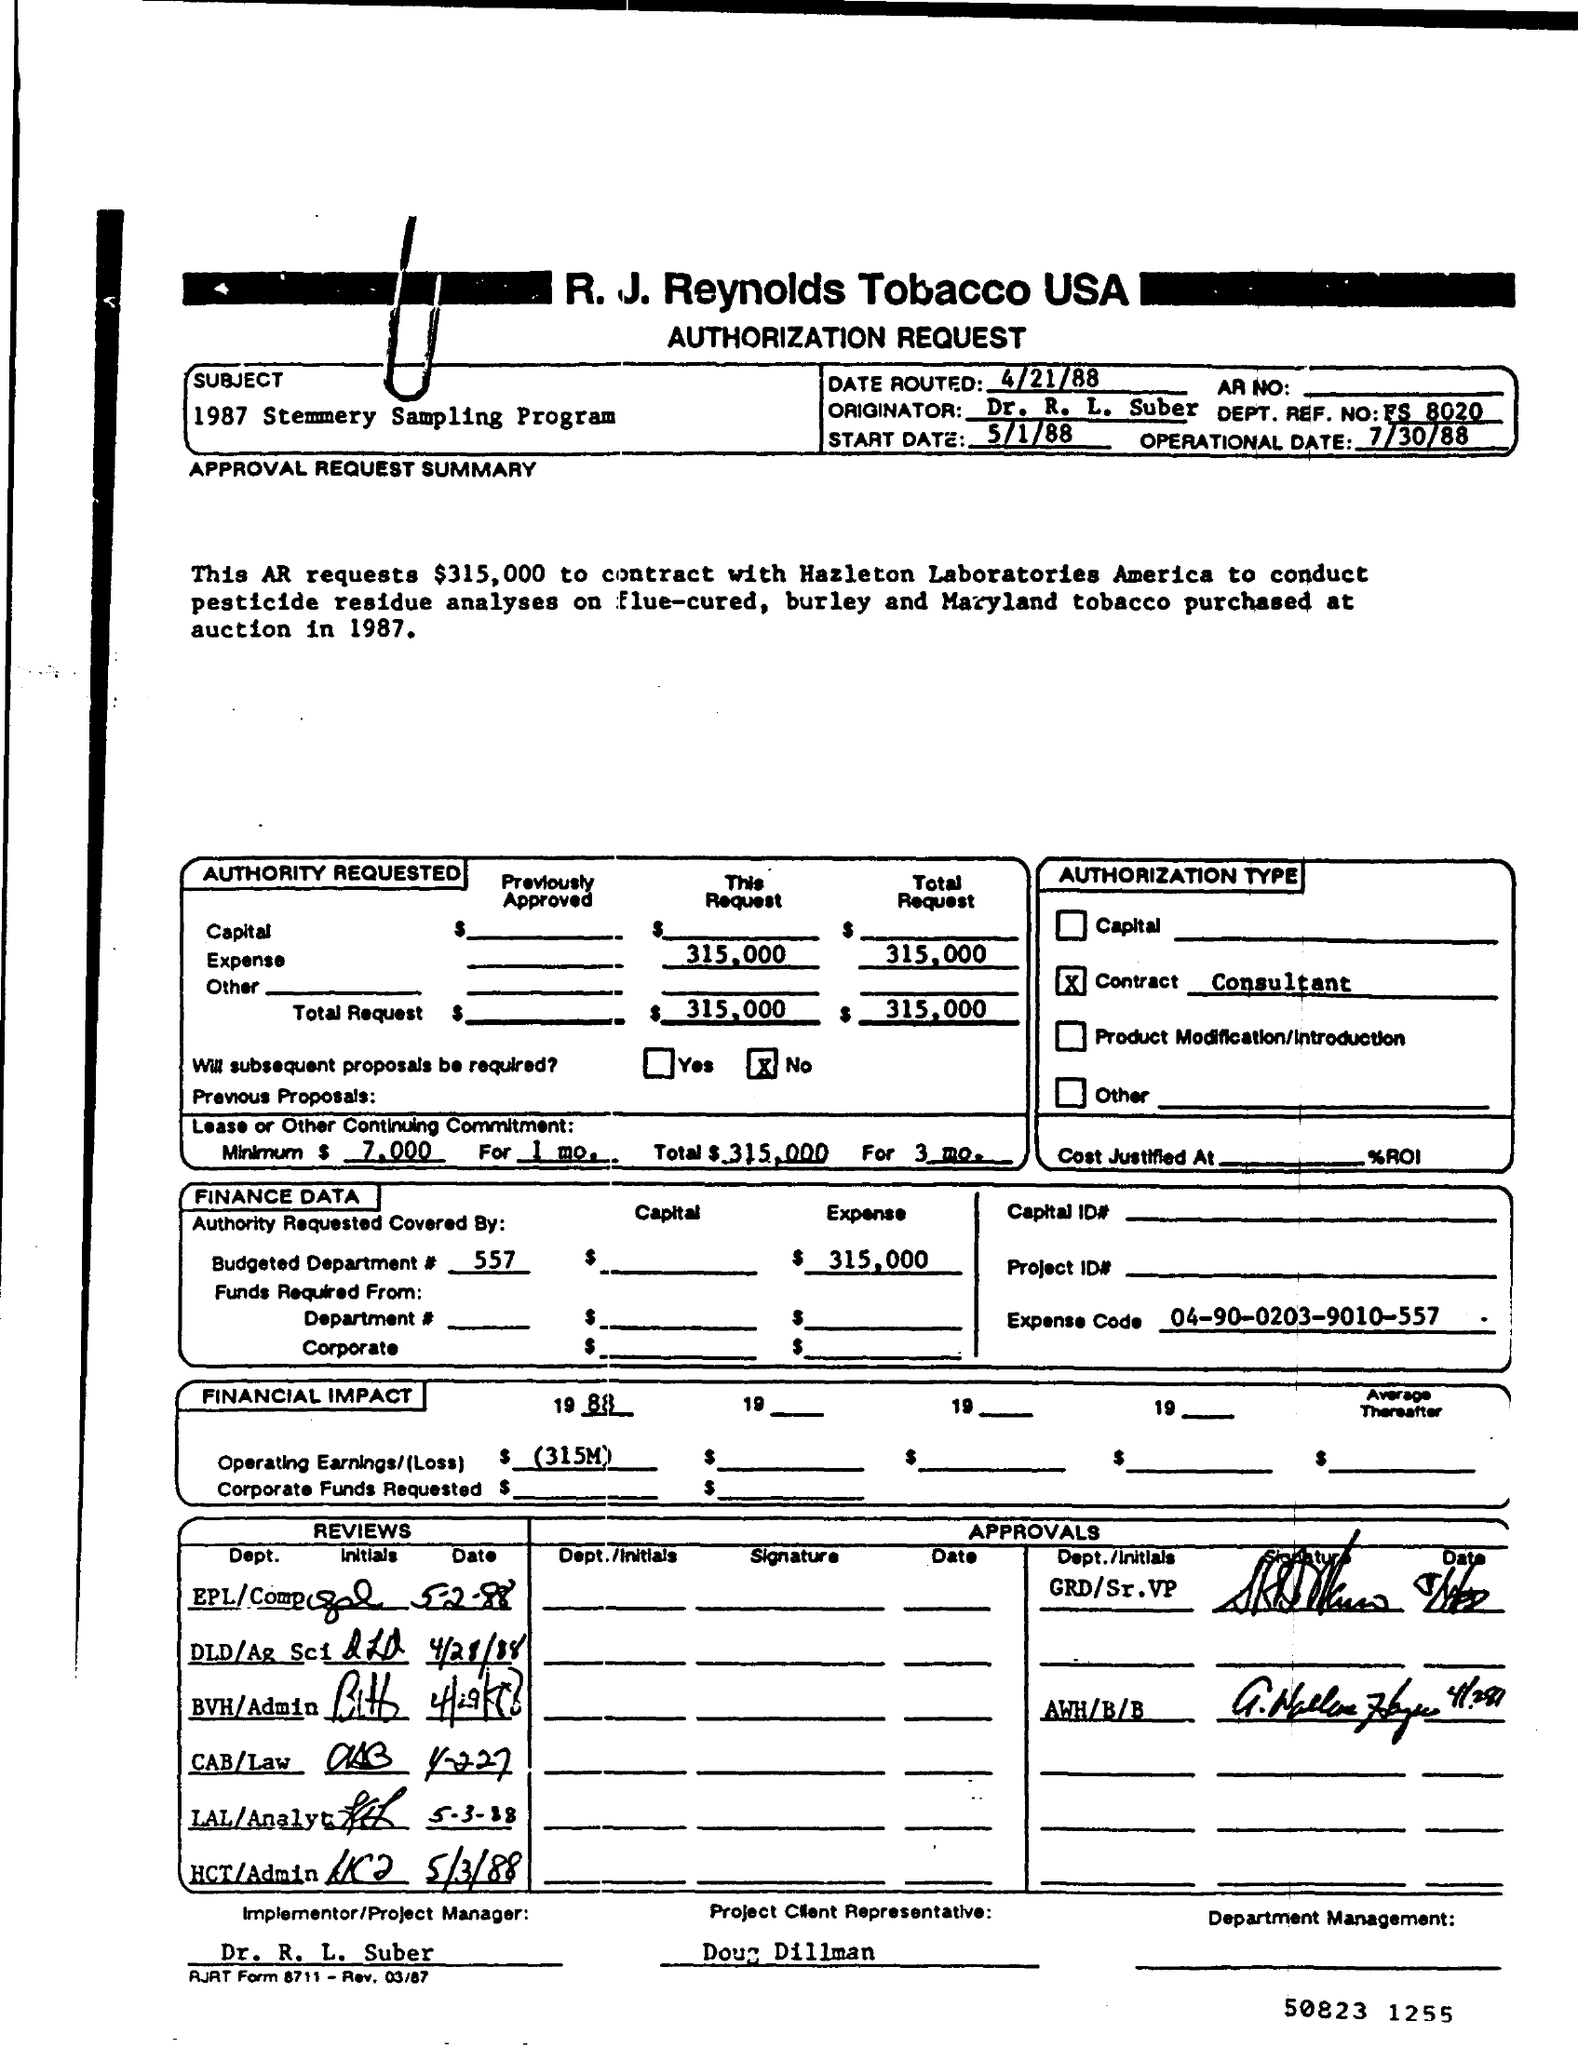Highlight a few significant elements in this photo. The expense code is 04-90-0203-9010-557... The subject is a 1987 stemmery sampling program. What is date routed?" refers to the information conveyed by the text "4/21/88," which appears to be a date. Doug Dillman is the client representative for the project. What is the DEPT. REF. NO. FS 8020.." is a reference number used in a department. 